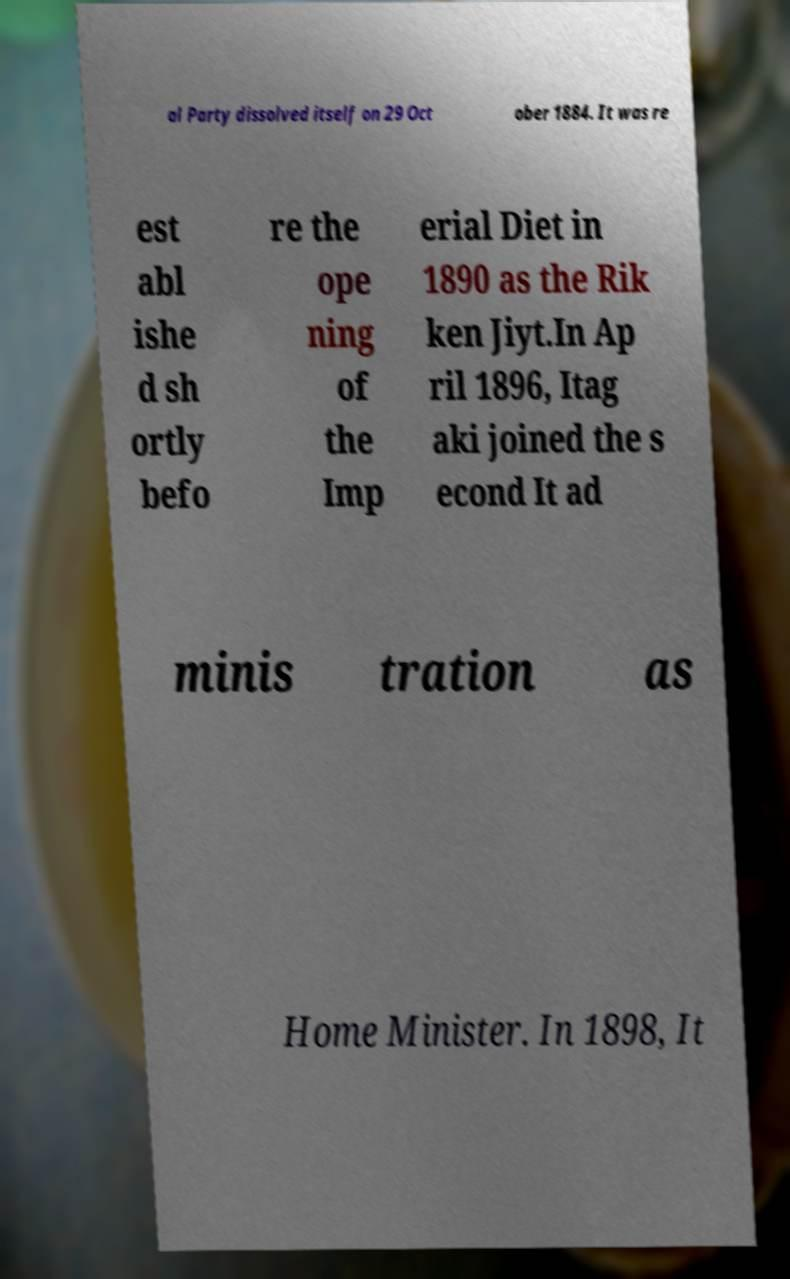Please identify and transcribe the text found in this image. al Party dissolved itself on 29 Oct ober 1884. It was re est abl ishe d sh ortly befo re the ope ning of the Imp erial Diet in 1890 as the Rik ken Jiyt.In Ap ril 1896, Itag aki joined the s econd It ad minis tration as Home Minister. In 1898, It 